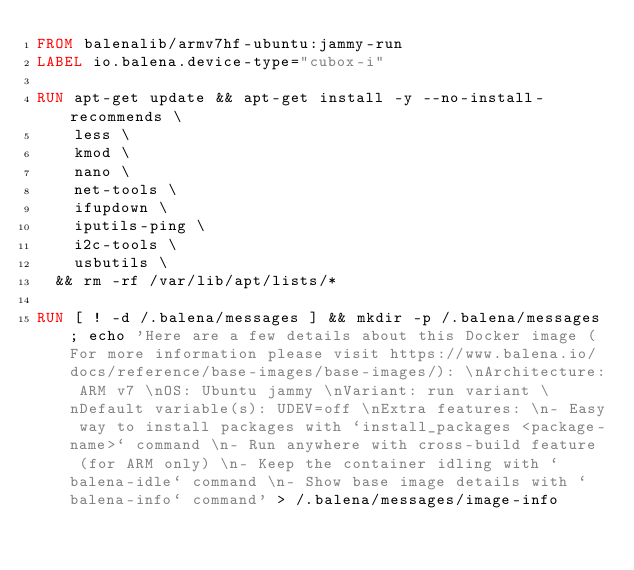Convert code to text. <code><loc_0><loc_0><loc_500><loc_500><_Dockerfile_>FROM balenalib/armv7hf-ubuntu:jammy-run
LABEL io.balena.device-type="cubox-i"

RUN apt-get update && apt-get install -y --no-install-recommends \
		less \
		kmod \
		nano \
		net-tools \
		ifupdown \
		iputils-ping \
		i2c-tools \
		usbutils \
	&& rm -rf /var/lib/apt/lists/*

RUN [ ! -d /.balena/messages ] && mkdir -p /.balena/messages; echo 'Here are a few details about this Docker image (For more information please visit https://www.balena.io/docs/reference/base-images/base-images/): \nArchitecture: ARM v7 \nOS: Ubuntu jammy \nVariant: run variant \nDefault variable(s): UDEV=off \nExtra features: \n- Easy way to install packages with `install_packages <package-name>` command \n- Run anywhere with cross-build feature  (for ARM only) \n- Keep the container idling with `balena-idle` command \n- Show base image details with `balena-info` command' > /.balena/messages/image-info</code> 